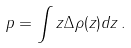Convert formula to latex. <formula><loc_0><loc_0><loc_500><loc_500>p = \int z \Delta \rho ( z ) d z \, .</formula> 